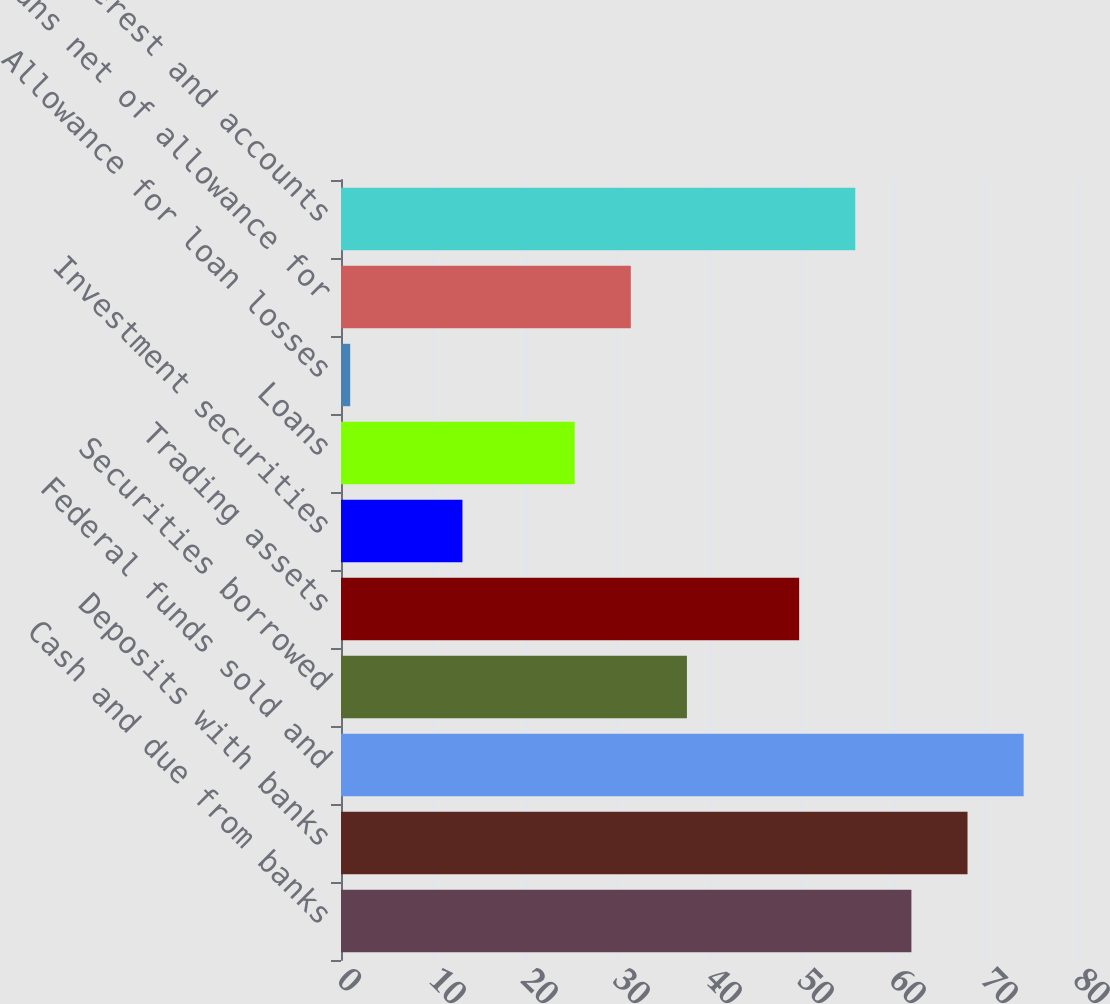Convert chart to OTSL. <chart><loc_0><loc_0><loc_500><loc_500><bar_chart><fcel>Cash and due from banks<fcel>Deposits with banks<fcel>Federal funds sold and<fcel>Securities borrowed<fcel>Trading assets<fcel>Investment securities<fcel>Loans<fcel>Allowance for loan losses<fcel>Loans net of allowance for<fcel>Accrued interest and accounts<nl><fcel>62<fcel>68.1<fcel>74.2<fcel>37.6<fcel>49.8<fcel>13.2<fcel>25.4<fcel>1<fcel>31.5<fcel>55.9<nl></chart> 